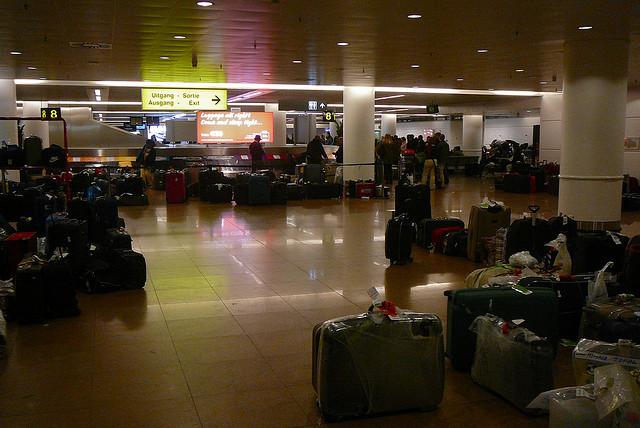Is there a bicycle in this picture?
Keep it brief. No. Does this airport have good lighting?
Write a very short answer. No. Are these people waiting to get on a plane?
Write a very short answer. Yes. Could there be a flight delay?
Write a very short answer. Yes. Are there any humans?
Concise answer only. Yes. 